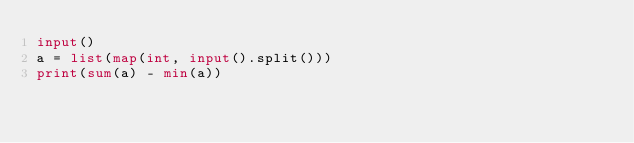<code> <loc_0><loc_0><loc_500><loc_500><_Python_>input()
a = list(map(int, input().split()))
print(sum(a) - min(a))</code> 